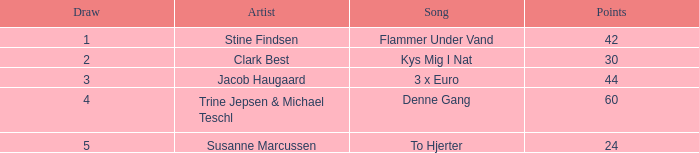What is the mean draw when the location is greater than 5? None. 